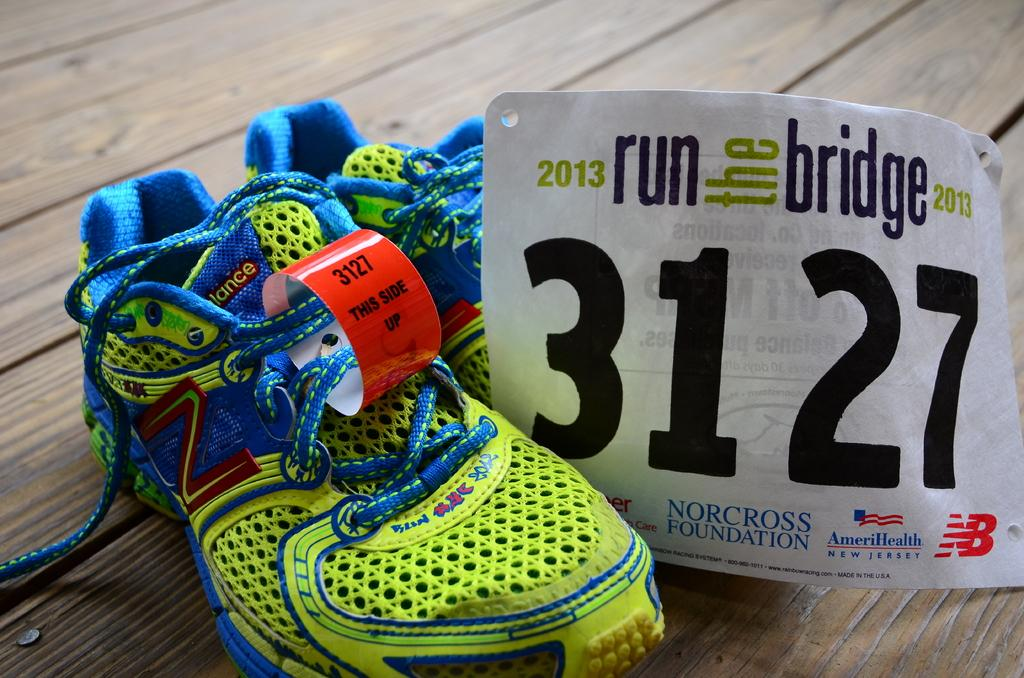What colors are the shoes in the foreground of the image? The shoes are green and blue. What type of surface are the shoes placed on? The shoes are on a wooden surface. What distinguishing feature do the laces of the shoes have? The laces have a red strip. What else can be seen on the wooden surface besides the shoes? There is a paper on the wooden surface. Can you see the feet inside the shoes in the image? No, the image only shows the shoes themselves and not the feet inside them. Is there a horn visible on the wooden surface in the image? No, there is no horn present in the image. 